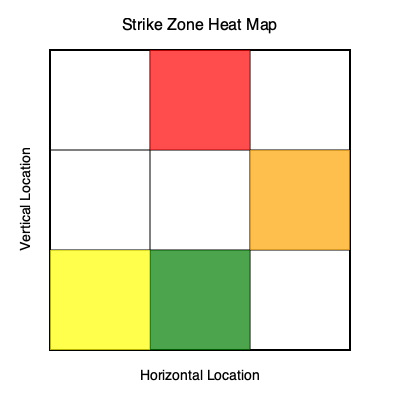Based on the strike zone heat map provided, which area of the strike zone should the pitcher focus on improving to maximize their effectiveness, and why would this be particularly valuable for their career prospects? 1. Analyze the heat map:
   - Red (top-middle): High concentration of strikes
   - Orange (top-right): Moderate concentration of strikes
   - Yellow (bottom-left): Low concentration of strikes
   - Green (bottom-middle): Very low concentration of strikes

2. Identify the weakest area:
   The bottom-middle (green) area shows the lowest concentration of strikes, indicating the pitcher's least effective zone.

3. Consider improvement potential:
   Focusing on the bottom-middle area would balance the pitcher's effectiveness across the strike zone, making them less predictable.

4. Evaluate career impact:
   - Improved lower strike zone control often leads to more ground balls, which are valuable for run prevention.
   - A balanced strike zone approach makes the pitcher more versatile and adaptable to different batting strategies.
   - Consistency across the strike zone is highly valued by MLB teams, potentially leading to better contract offers.

5. Agent's perspective:
   As a sports agent, recommending this improvement would enhance the pitcher's marketability and negotiating power for future contracts.
Answer: Bottom-middle; increases versatility and ground ball potential, enhancing marketability. 